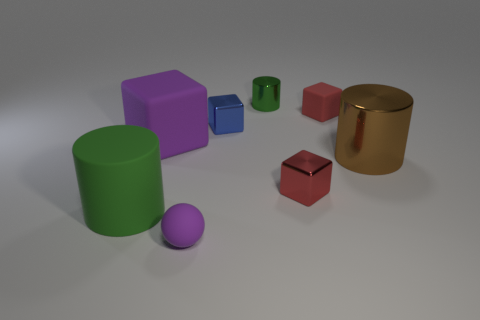Add 1 purple matte objects. How many purple matte objects are left? 3 Add 4 small spheres. How many small spheres exist? 5 Add 1 gray rubber blocks. How many objects exist? 9 Subtract all brown cylinders. How many cylinders are left? 2 Subtract all green cylinders. How many cylinders are left? 1 Subtract 0 cyan cylinders. How many objects are left? 8 Subtract all spheres. How many objects are left? 7 Subtract 2 blocks. How many blocks are left? 2 Subtract all purple cylinders. Subtract all brown balls. How many cylinders are left? 3 Subtract all cyan cubes. How many cyan spheres are left? 0 